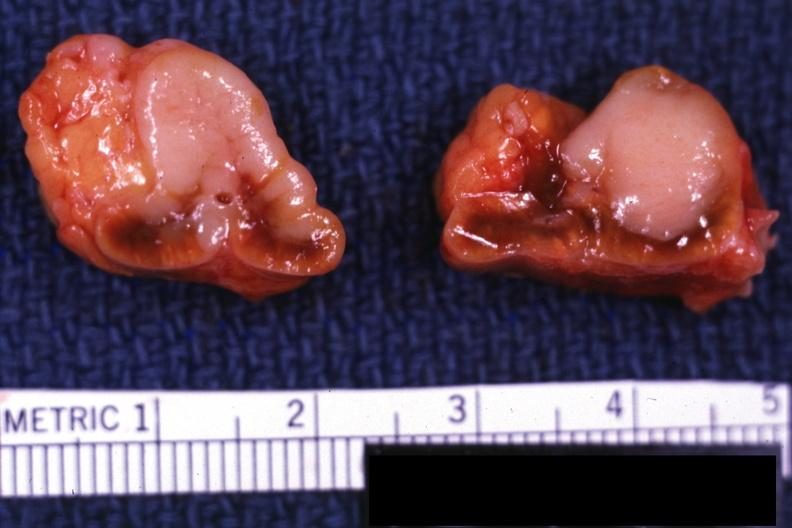what does this image show?
Answer the question using a single word or phrase. Sectioned gland bilateral lesions excellent example 